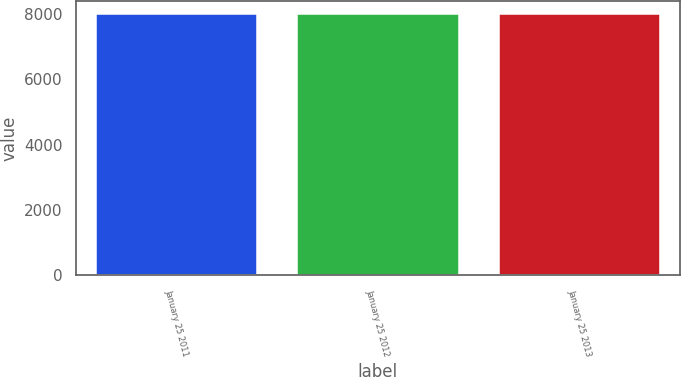Convert chart to OTSL. <chart><loc_0><loc_0><loc_500><loc_500><bar_chart><fcel>January 25 2011<fcel>January 25 2012<fcel>January 25 2013<nl><fcel>8000<fcel>8000.1<fcel>8000.2<nl></chart> 